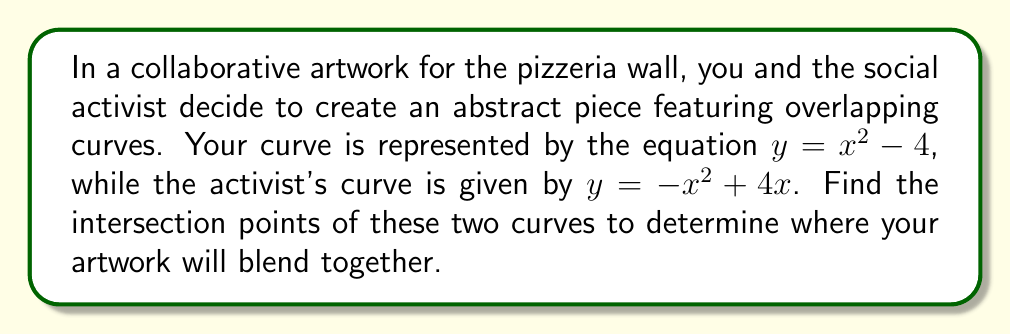Solve this math problem. To find the intersection points, we need to solve the system of equations:

$$\begin{cases}
y = x^2 - 4 \\
y = -x^2 + 4x
\end{cases}$$

1) Set the equations equal to each other:
   $x^2 - 4 = -x^2 + 4x$

2) Rearrange the equation:
   $2x^2 - 4x - 4 = 0$

3) This is a quadratic equation. Let's solve it using the quadratic formula:
   $x = \frac{-b \pm \sqrt{b^2 - 4ac}}{2a}$

   Where $a=2$, $b=-4$, and $c=-4$

4) Substituting these values:
   $x = \frac{4 \pm \sqrt{16 + 32}}{4} = \frac{4 \pm \sqrt{48}}{4} = \frac{4 \pm 4\sqrt{3}}{4}$

5) Simplify:
   $x = 1 \pm \sqrt{3}$

6) So, the x-coordinates of the intersection points are:
   $x_1 = 1 + \sqrt{3}$ and $x_2 = 1 - \sqrt{3}$

7) To find the y-coordinates, substitute these x-values into either of the original equations. Let's use $y = x^2 - 4$:

   For $x_1$: $y = (1 + \sqrt{3})^2 - 4 = 1 + 2\sqrt{3} + 3 - 4 = 2\sqrt{3}$
   For $x_2$: $y = (1 - \sqrt{3})^2 - 4 = 1 - 2\sqrt{3} + 3 - 4 = -2\sqrt{3}$

Therefore, the intersection points are $(1 + \sqrt{3}, 2\sqrt{3})$ and $(1 - \sqrt{3}, -2\sqrt{3})$.
Answer: $(1 + \sqrt{3}, 2\sqrt{3})$ and $(1 - \sqrt{3}, -2\sqrt{3})$ 